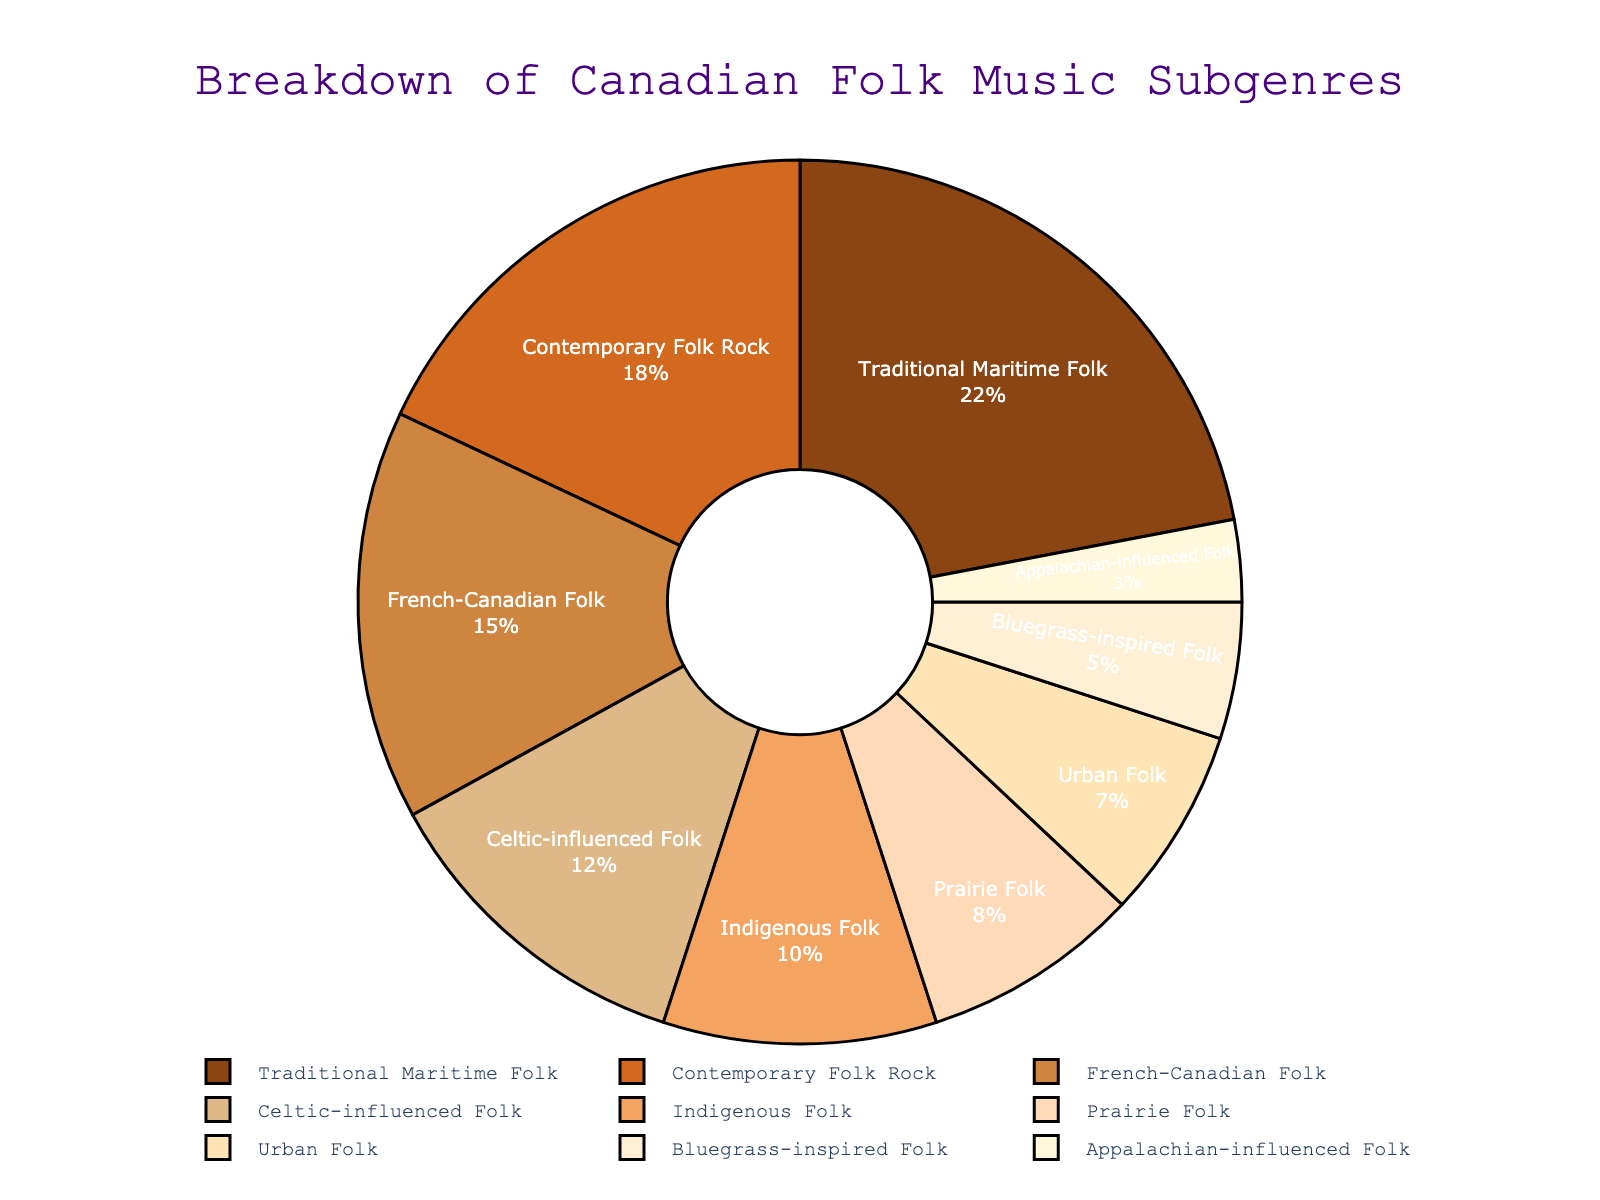Which subgenre has the highest popularity percentage? By examining the pie chart, the subgenre with the largest segment represents the most popular subgenre. The "Traditional Maritime Folk" section is the largest at 22%.
Answer: Traditional Maritime Folk Which subgenre has the lowest popularity percentage? Looking at the pie chart, the smallest segment represents the least popular subgenre. The "Appalachian-influenced Folk" section is the smallest at 3%.
Answer: Appalachian-influenced Folk How much more popular is "Traditional Maritime Folk" compared to "Appalachian-influenced Folk"? "Traditional Maritime Folk" has 22%, and "Appalachian-influenced Folk" has 3%. Subtracting these gives 22 - 3 = 19%.
Answer: 19% What is the combined percentage of "Contemporary Folk Rock" and "Celtic-influenced Folk"? "Contemporary Folk Rock" is 18%, and "Celtic-influenced Folk" is 12%. Adding these gives 18 + 12 = 30%.
Answer: 30% Which is more popular, "French-Canadian Folk" or "Prairie Folk"? By how much? "French-Canadian Folk" has a popularity of 15%, while "Prairie Folk" has 8%. Subtracting these gives 15 - 8 = 7%.
Answer: French-Canadian Folk, by 7% What is the percentage difference between "Indigenous Folk" and "Urban Folk"? "Indigenous Folk" is 10%, and "Urban Folk" is 7%. Subtracting these gives 10 - 7 = 3%.
Answer: 3% What is the total popularity percentage of subgenres with less than 10% popularity? The subgenres are: "Prairie Folk" (8%), "Urban Folk" (7%), "Bluegrass-inspired Folk" (5%), and "Appalachian-influenced Folk" (3%). Adding these gives 8 + 7 + 5 + 3 = 23%.
Answer: 23% How many subgenres have a popularity percentage higher than "Celtic-influenced Folk"? "Celtic-influenced Folk" has a popularity of 12%. The subgenres above this percentage are "Traditional Maritime Folk" (22%), "Contemporary Folk Rock" (18%), and "French-Canadian Folk" (15%). That accounts for 3 subgenres.
Answer: 3 